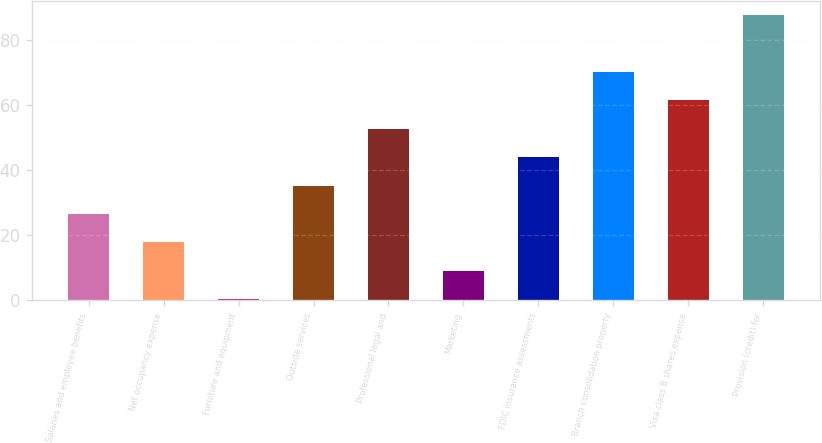Convert chart. <chart><loc_0><loc_0><loc_500><loc_500><bar_chart><fcel>Salaries and employee benefits<fcel>Net occupancy expense<fcel>Furniture and equipment<fcel>Outside services<fcel>Professional legal and<fcel>Marketing<fcel>FDIC insurance assessments<fcel>Branch consolidation property<fcel>Visa class B shares expense<fcel>Provision (credit) for<nl><fcel>26.46<fcel>17.74<fcel>0.3<fcel>35.18<fcel>52.62<fcel>9.02<fcel>43.9<fcel>70.06<fcel>61.34<fcel>87.5<nl></chart> 